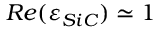<formula> <loc_0><loc_0><loc_500><loc_500>R e ( \varepsilon _ { S i C } ) \simeq 1</formula> 